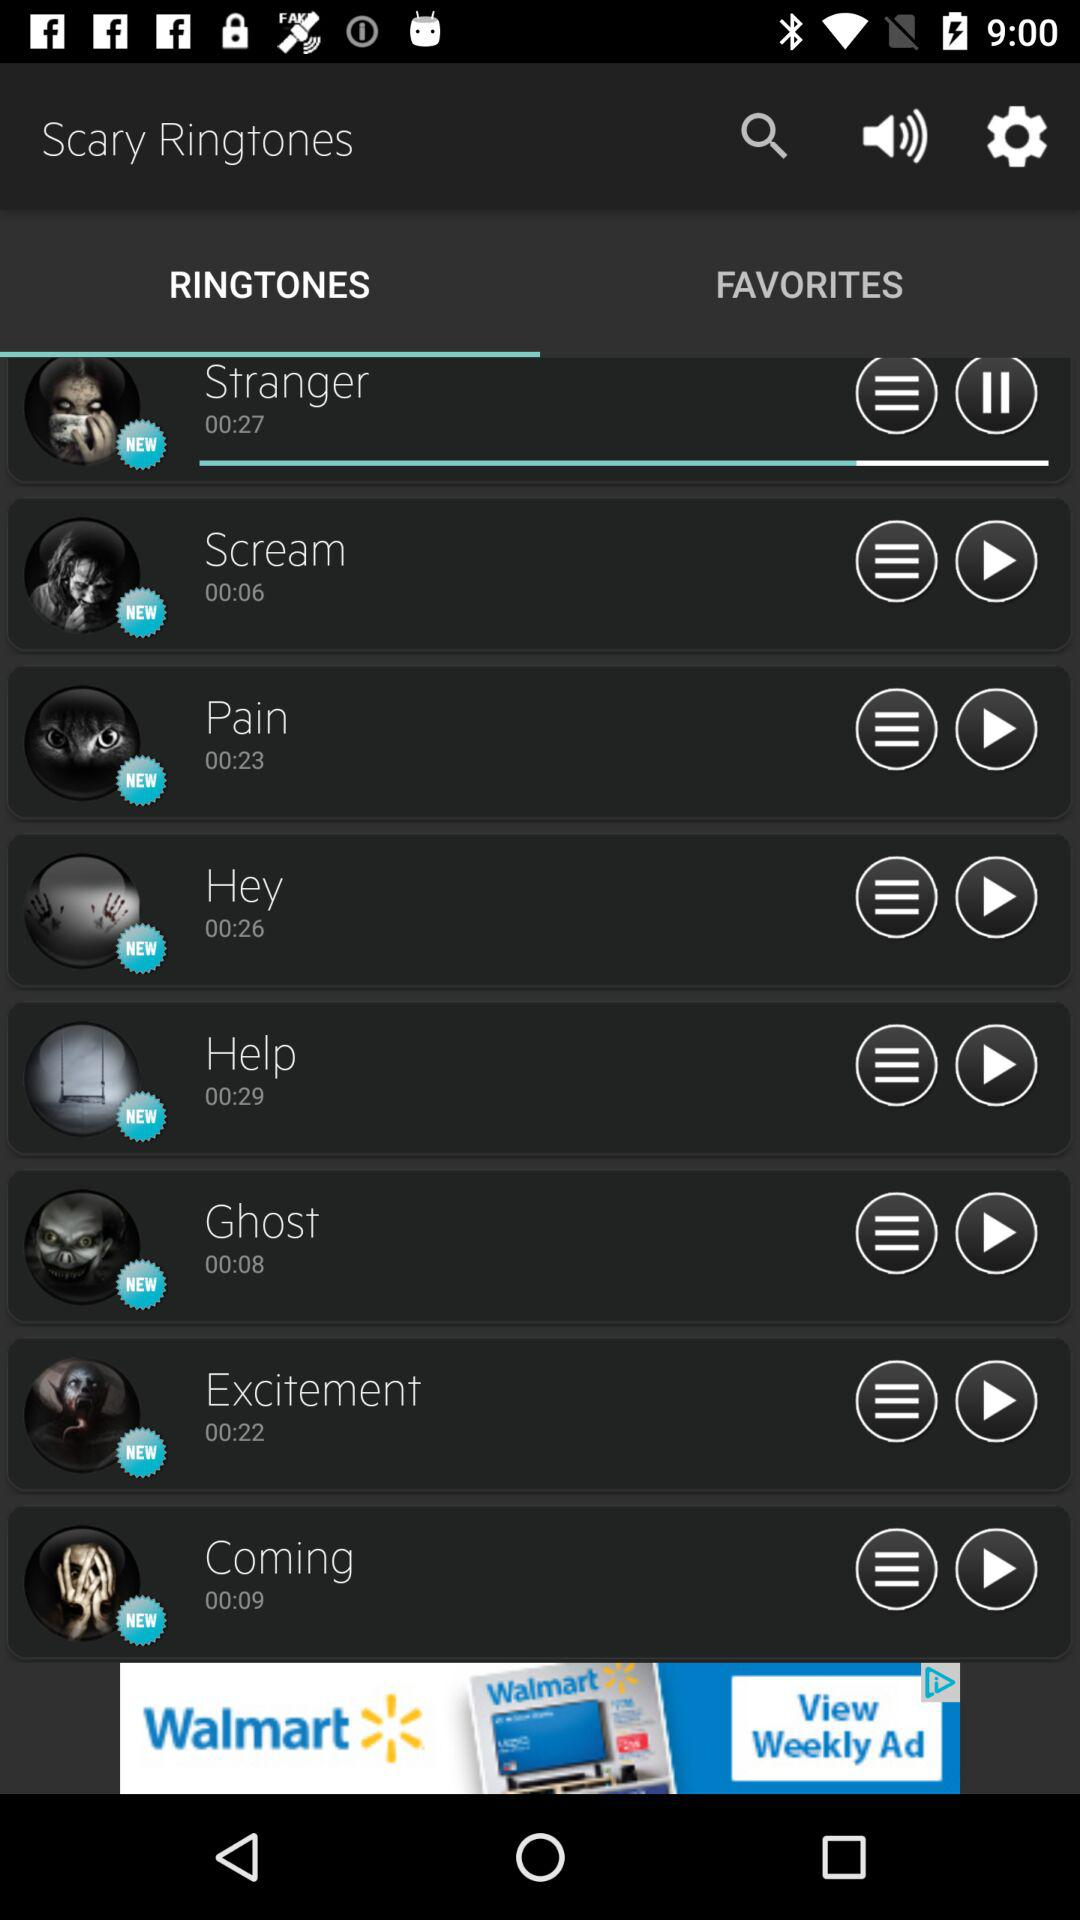On which tab are we? We are on the ringtones tab. 